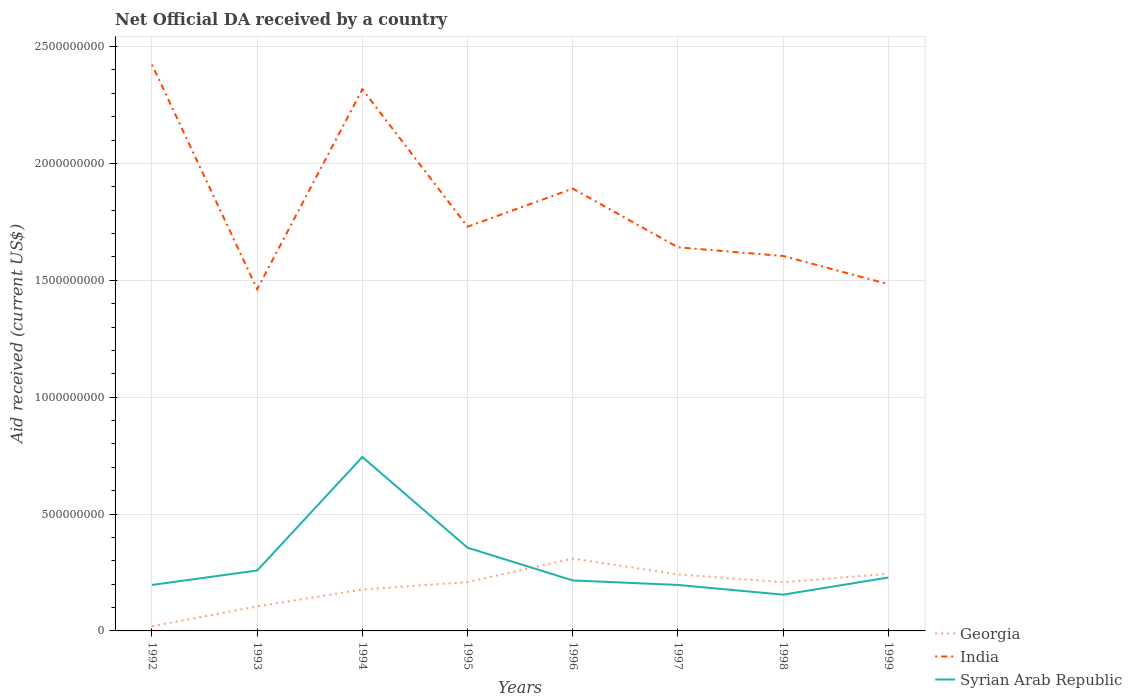How many different coloured lines are there?
Your answer should be very brief. 3. Is the number of lines equal to the number of legend labels?
Your answer should be compact. Yes. Across all years, what is the maximum net official development assistance aid received in Syrian Arab Republic?
Give a very brief answer. 1.55e+08. In which year was the net official development assistance aid received in India maximum?
Provide a short and direct response. 1993. What is the total net official development assistance aid received in Georgia in the graph?
Give a very brief answer. -2.24e+08. What is the difference between the highest and the second highest net official development assistance aid received in Georgia?
Keep it short and to the point. 2.89e+08. What is the difference between the highest and the lowest net official development assistance aid received in India?
Offer a terse response. 3. How many years are there in the graph?
Ensure brevity in your answer.  8. What is the difference between two consecutive major ticks on the Y-axis?
Ensure brevity in your answer.  5.00e+08. How many legend labels are there?
Keep it short and to the point. 3. How are the legend labels stacked?
Provide a short and direct response. Vertical. What is the title of the graph?
Ensure brevity in your answer.  Net Official DA received by a country. What is the label or title of the Y-axis?
Provide a short and direct response. Aid received (current US$). What is the Aid received (current US$) in Georgia in 1992?
Your response must be concise. 2.04e+07. What is the Aid received (current US$) of India in 1992?
Provide a short and direct response. 2.42e+09. What is the Aid received (current US$) in Syrian Arab Republic in 1992?
Provide a short and direct response. 1.97e+08. What is the Aid received (current US$) of Georgia in 1993?
Offer a very short reply. 1.05e+08. What is the Aid received (current US$) of India in 1993?
Offer a very short reply. 1.46e+09. What is the Aid received (current US$) in Syrian Arab Republic in 1993?
Provide a short and direct response. 2.59e+08. What is the Aid received (current US$) in Georgia in 1994?
Keep it short and to the point. 1.77e+08. What is the Aid received (current US$) of India in 1994?
Offer a terse response. 2.32e+09. What is the Aid received (current US$) of Syrian Arab Republic in 1994?
Make the answer very short. 7.44e+08. What is the Aid received (current US$) in Georgia in 1995?
Keep it short and to the point. 2.09e+08. What is the Aid received (current US$) in India in 1995?
Provide a succinct answer. 1.73e+09. What is the Aid received (current US$) of Syrian Arab Republic in 1995?
Your answer should be very brief. 3.56e+08. What is the Aid received (current US$) of Georgia in 1996?
Offer a terse response. 3.09e+08. What is the Aid received (current US$) in India in 1996?
Your response must be concise. 1.89e+09. What is the Aid received (current US$) of Syrian Arab Republic in 1996?
Give a very brief answer. 2.16e+08. What is the Aid received (current US$) in Georgia in 1997?
Your answer should be very brief. 2.42e+08. What is the Aid received (current US$) of India in 1997?
Offer a very short reply. 1.64e+09. What is the Aid received (current US$) of Syrian Arab Republic in 1997?
Ensure brevity in your answer.  1.97e+08. What is the Aid received (current US$) in Georgia in 1998?
Keep it short and to the point. 2.09e+08. What is the Aid received (current US$) of India in 1998?
Ensure brevity in your answer.  1.60e+09. What is the Aid received (current US$) in Syrian Arab Republic in 1998?
Give a very brief answer. 1.55e+08. What is the Aid received (current US$) of Georgia in 1999?
Keep it short and to the point. 2.44e+08. What is the Aid received (current US$) in India in 1999?
Provide a succinct answer. 1.48e+09. What is the Aid received (current US$) in Syrian Arab Republic in 1999?
Offer a terse response. 2.28e+08. Across all years, what is the maximum Aid received (current US$) in Georgia?
Make the answer very short. 3.09e+08. Across all years, what is the maximum Aid received (current US$) in India?
Ensure brevity in your answer.  2.42e+09. Across all years, what is the maximum Aid received (current US$) in Syrian Arab Republic?
Give a very brief answer. 7.44e+08. Across all years, what is the minimum Aid received (current US$) of Georgia?
Offer a terse response. 2.04e+07. Across all years, what is the minimum Aid received (current US$) of India?
Ensure brevity in your answer.  1.46e+09. Across all years, what is the minimum Aid received (current US$) in Syrian Arab Republic?
Give a very brief answer. 1.55e+08. What is the total Aid received (current US$) in Georgia in the graph?
Ensure brevity in your answer.  1.52e+09. What is the total Aid received (current US$) in India in the graph?
Give a very brief answer. 1.46e+1. What is the total Aid received (current US$) of Syrian Arab Republic in the graph?
Keep it short and to the point. 2.35e+09. What is the difference between the Aid received (current US$) of Georgia in 1992 and that in 1993?
Your response must be concise. -8.44e+07. What is the difference between the Aid received (current US$) of India in 1992 and that in 1993?
Provide a short and direct response. 9.61e+08. What is the difference between the Aid received (current US$) of Syrian Arab Republic in 1992 and that in 1993?
Your answer should be compact. -6.18e+07. What is the difference between the Aid received (current US$) in Georgia in 1992 and that in 1994?
Keep it short and to the point. -1.57e+08. What is the difference between the Aid received (current US$) of India in 1992 and that in 1994?
Give a very brief answer. 1.05e+08. What is the difference between the Aid received (current US$) of Syrian Arab Republic in 1992 and that in 1994?
Give a very brief answer. -5.47e+08. What is the difference between the Aid received (current US$) in Georgia in 1992 and that in 1995?
Offer a terse response. -1.89e+08. What is the difference between the Aid received (current US$) in India in 1992 and that in 1995?
Your response must be concise. 6.93e+08. What is the difference between the Aid received (current US$) in Syrian Arab Republic in 1992 and that in 1995?
Provide a short and direct response. -1.59e+08. What is the difference between the Aid received (current US$) of Georgia in 1992 and that in 1996?
Keep it short and to the point. -2.89e+08. What is the difference between the Aid received (current US$) in India in 1992 and that in 1996?
Your answer should be very brief. 5.30e+08. What is the difference between the Aid received (current US$) in Syrian Arab Republic in 1992 and that in 1996?
Ensure brevity in your answer.  -1.92e+07. What is the difference between the Aid received (current US$) in Georgia in 1992 and that in 1997?
Provide a short and direct response. -2.22e+08. What is the difference between the Aid received (current US$) in India in 1992 and that in 1997?
Your response must be concise. 7.82e+08. What is the difference between the Aid received (current US$) of Syrian Arab Republic in 1992 and that in 1997?
Ensure brevity in your answer.  5.00e+04. What is the difference between the Aid received (current US$) in Georgia in 1992 and that in 1998?
Ensure brevity in your answer.  -1.88e+08. What is the difference between the Aid received (current US$) of India in 1992 and that in 1998?
Your response must be concise. 8.19e+08. What is the difference between the Aid received (current US$) of Syrian Arab Republic in 1992 and that in 1998?
Provide a succinct answer. 4.16e+07. What is the difference between the Aid received (current US$) in Georgia in 1992 and that in 1999?
Offer a terse response. -2.24e+08. What is the difference between the Aid received (current US$) of India in 1992 and that in 1999?
Your response must be concise. 9.39e+08. What is the difference between the Aid received (current US$) in Syrian Arab Republic in 1992 and that in 1999?
Keep it short and to the point. -3.18e+07. What is the difference between the Aid received (current US$) in Georgia in 1993 and that in 1994?
Make the answer very short. -7.25e+07. What is the difference between the Aid received (current US$) of India in 1993 and that in 1994?
Your response must be concise. -8.55e+08. What is the difference between the Aid received (current US$) of Syrian Arab Republic in 1993 and that in 1994?
Provide a short and direct response. -4.85e+08. What is the difference between the Aid received (current US$) in Georgia in 1993 and that in 1995?
Offer a very short reply. -1.04e+08. What is the difference between the Aid received (current US$) of India in 1993 and that in 1995?
Offer a terse response. -2.67e+08. What is the difference between the Aid received (current US$) in Syrian Arab Republic in 1993 and that in 1995?
Give a very brief answer. -9.74e+07. What is the difference between the Aid received (current US$) in Georgia in 1993 and that in 1996?
Keep it short and to the point. -2.05e+08. What is the difference between the Aid received (current US$) of India in 1993 and that in 1996?
Your response must be concise. -4.30e+08. What is the difference between the Aid received (current US$) in Syrian Arab Republic in 1993 and that in 1996?
Provide a short and direct response. 4.26e+07. What is the difference between the Aid received (current US$) in Georgia in 1993 and that in 1997?
Give a very brief answer. -1.37e+08. What is the difference between the Aid received (current US$) of India in 1993 and that in 1997?
Keep it short and to the point. -1.79e+08. What is the difference between the Aid received (current US$) of Syrian Arab Republic in 1993 and that in 1997?
Provide a short and direct response. 6.19e+07. What is the difference between the Aid received (current US$) of Georgia in 1993 and that in 1998?
Provide a short and direct response. -1.04e+08. What is the difference between the Aid received (current US$) of India in 1993 and that in 1998?
Your response must be concise. -1.42e+08. What is the difference between the Aid received (current US$) of Syrian Arab Republic in 1993 and that in 1998?
Offer a terse response. 1.03e+08. What is the difference between the Aid received (current US$) of Georgia in 1993 and that in 1999?
Provide a short and direct response. -1.40e+08. What is the difference between the Aid received (current US$) of India in 1993 and that in 1999?
Ensure brevity in your answer.  -2.14e+07. What is the difference between the Aid received (current US$) of Syrian Arab Republic in 1993 and that in 1999?
Your answer should be compact. 3.01e+07. What is the difference between the Aid received (current US$) of Georgia in 1994 and that in 1995?
Provide a short and direct response. -3.17e+07. What is the difference between the Aid received (current US$) of India in 1994 and that in 1995?
Ensure brevity in your answer.  5.88e+08. What is the difference between the Aid received (current US$) in Syrian Arab Republic in 1994 and that in 1995?
Your answer should be compact. 3.88e+08. What is the difference between the Aid received (current US$) in Georgia in 1994 and that in 1996?
Keep it short and to the point. -1.32e+08. What is the difference between the Aid received (current US$) in India in 1994 and that in 1996?
Make the answer very short. 4.25e+08. What is the difference between the Aid received (current US$) of Syrian Arab Republic in 1994 and that in 1996?
Your answer should be very brief. 5.28e+08. What is the difference between the Aid received (current US$) of Georgia in 1994 and that in 1997?
Make the answer very short. -6.46e+07. What is the difference between the Aid received (current US$) of India in 1994 and that in 1997?
Offer a terse response. 6.76e+08. What is the difference between the Aid received (current US$) of Syrian Arab Republic in 1994 and that in 1997?
Make the answer very short. 5.47e+08. What is the difference between the Aid received (current US$) in Georgia in 1994 and that in 1998?
Give a very brief answer. -3.12e+07. What is the difference between the Aid received (current US$) in India in 1994 and that in 1998?
Ensure brevity in your answer.  7.13e+08. What is the difference between the Aid received (current US$) of Syrian Arab Republic in 1994 and that in 1998?
Ensure brevity in your answer.  5.89e+08. What is the difference between the Aid received (current US$) of Georgia in 1994 and that in 1999?
Provide a short and direct response. -6.70e+07. What is the difference between the Aid received (current US$) in India in 1994 and that in 1999?
Give a very brief answer. 8.34e+08. What is the difference between the Aid received (current US$) of Syrian Arab Republic in 1994 and that in 1999?
Offer a terse response. 5.16e+08. What is the difference between the Aid received (current US$) of Georgia in 1995 and that in 1996?
Give a very brief answer. -1.00e+08. What is the difference between the Aid received (current US$) in India in 1995 and that in 1996?
Your response must be concise. -1.63e+08. What is the difference between the Aid received (current US$) of Syrian Arab Republic in 1995 and that in 1996?
Give a very brief answer. 1.40e+08. What is the difference between the Aid received (current US$) of Georgia in 1995 and that in 1997?
Provide a succinct answer. -3.28e+07. What is the difference between the Aid received (current US$) in India in 1995 and that in 1997?
Provide a short and direct response. 8.81e+07. What is the difference between the Aid received (current US$) in Syrian Arab Republic in 1995 and that in 1997?
Your response must be concise. 1.59e+08. What is the difference between the Aid received (current US$) of Georgia in 1995 and that in 1998?
Offer a very short reply. 5.40e+05. What is the difference between the Aid received (current US$) in India in 1995 and that in 1998?
Your answer should be compact. 1.25e+08. What is the difference between the Aid received (current US$) of Syrian Arab Republic in 1995 and that in 1998?
Make the answer very short. 2.01e+08. What is the difference between the Aid received (current US$) of Georgia in 1995 and that in 1999?
Your answer should be very brief. -3.53e+07. What is the difference between the Aid received (current US$) of India in 1995 and that in 1999?
Your response must be concise. 2.46e+08. What is the difference between the Aid received (current US$) in Syrian Arab Republic in 1995 and that in 1999?
Ensure brevity in your answer.  1.27e+08. What is the difference between the Aid received (current US$) of Georgia in 1996 and that in 1997?
Ensure brevity in your answer.  6.75e+07. What is the difference between the Aid received (current US$) of India in 1996 and that in 1997?
Make the answer very short. 2.51e+08. What is the difference between the Aid received (current US$) in Syrian Arab Republic in 1996 and that in 1997?
Your response must be concise. 1.93e+07. What is the difference between the Aid received (current US$) of Georgia in 1996 and that in 1998?
Your response must be concise. 1.01e+08. What is the difference between the Aid received (current US$) of India in 1996 and that in 1998?
Your response must be concise. 2.88e+08. What is the difference between the Aid received (current US$) of Syrian Arab Republic in 1996 and that in 1998?
Offer a terse response. 6.08e+07. What is the difference between the Aid received (current US$) in Georgia in 1996 and that in 1999?
Keep it short and to the point. 6.50e+07. What is the difference between the Aid received (current US$) of India in 1996 and that in 1999?
Offer a terse response. 4.09e+08. What is the difference between the Aid received (current US$) in Syrian Arab Republic in 1996 and that in 1999?
Provide a short and direct response. -1.25e+07. What is the difference between the Aid received (current US$) of Georgia in 1997 and that in 1998?
Keep it short and to the point. 3.34e+07. What is the difference between the Aid received (current US$) in India in 1997 and that in 1998?
Your answer should be very brief. 3.71e+07. What is the difference between the Aid received (current US$) in Syrian Arab Republic in 1997 and that in 1998?
Give a very brief answer. 4.16e+07. What is the difference between the Aid received (current US$) in Georgia in 1997 and that in 1999?
Provide a succinct answer. -2.46e+06. What is the difference between the Aid received (current US$) in India in 1997 and that in 1999?
Offer a very short reply. 1.58e+08. What is the difference between the Aid received (current US$) of Syrian Arab Republic in 1997 and that in 1999?
Ensure brevity in your answer.  -3.18e+07. What is the difference between the Aid received (current US$) of Georgia in 1998 and that in 1999?
Ensure brevity in your answer.  -3.58e+07. What is the difference between the Aid received (current US$) of India in 1998 and that in 1999?
Offer a terse response. 1.21e+08. What is the difference between the Aid received (current US$) of Syrian Arab Republic in 1998 and that in 1999?
Provide a short and direct response. -7.34e+07. What is the difference between the Aid received (current US$) of Georgia in 1992 and the Aid received (current US$) of India in 1993?
Your answer should be very brief. -1.44e+09. What is the difference between the Aid received (current US$) of Georgia in 1992 and the Aid received (current US$) of Syrian Arab Republic in 1993?
Provide a succinct answer. -2.38e+08. What is the difference between the Aid received (current US$) in India in 1992 and the Aid received (current US$) in Syrian Arab Republic in 1993?
Give a very brief answer. 2.16e+09. What is the difference between the Aid received (current US$) of Georgia in 1992 and the Aid received (current US$) of India in 1994?
Keep it short and to the point. -2.30e+09. What is the difference between the Aid received (current US$) in Georgia in 1992 and the Aid received (current US$) in Syrian Arab Republic in 1994?
Make the answer very short. -7.24e+08. What is the difference between the Aid received (current US$) of India in 1992 and the Aid received (current US$) of Syrian Arab Republic in 1994?
Provide a short and direct response. 1.68e+09. What is the difference between the Aid received (current US$) of Georgia in 1992 and the Aid received (current US$) of India in 1995?
Offer a very short reply. -1.71e+09. What is the difference between the Aid received (current US$) of Georgia in 1992 and the Aid received (current US$) of Syrian Arab Republic in 1995?
Offer a terse response. -3.36e+08. What is the difference between the Aid received (current US$) in India in 1992 and the Aid received (current US$) in Syrian Arab Republic in 1995?
Your answer should be very brief. 2.07e+09. What is the difference between the Aid received (current US$) in Georgia in 1992 and the Aid received (current US$) in India in 1996?
Give a very brief answer. -1.87e+09. What is the difference between the Aid received (current US$) of Georgia in 1992 and the Aid received (current US$) of Syrian Arab Republic in 1996?
Provide a succinct answer. -1.96e+08. What is the difference between the Aid received (current US$) in India in 1992 and the Aid received (current US$) in Syrian Arab Republic in 1996?
Give a very brief answer. 2.21e+09. What is the difference between the Aid received (current US$) in Georgia in 1992 and the Aid received (current US$) in India in 1997?
Your response must be concise. -1.62e+09. What is the difference between the Aid received (current US$) of Georgia in 1992 and the Aid received (current US$) of Syrian Arab Republic in 1997?
Offer a very short reply. -1.76e+08. What is the difference between the Aid received (current US$) of India in 1992 and the Aid received (current US$) of Syrian Arab Republic in 1997?
Your answer should be compact. 2.23e+09. What is the difference between the Aid received (current US$) of Georgia in 1992 and the Aid received (current US$) of India in 1998?
Make the answer very short. -1.58e+09. What is the difference between the Aid received (current US$) of Georgia in 1992 and the Aid received (current US$) of Syrian Arab Republic in 1998?
Your response must be concise. -1.35e+08. What is the difference between the Aid received (current US$) of India in 1992 and the Aid received (current US$) of Syrian Arab Republic in 1998?
Your answer should be very brief. 2.27e+09. What is the difference between the Aid received (current US$) in Georgia in 1992 and the Aid received (current US$) in India in 1999?
Your response must be concise. -1.46e+09. What is the difference between the Aid received (current US$) in Georgia in 1992 and the Aid received (current US$) in Syrian Arab Republic in 1999?
Provide a succinct answer. -2.08e+08. What is the difference between the Aid received (current US$) of India in 1992 and the Aid received (current US$) of Syrian Arab Republic in 1999?
Your answer should be very brief. 2.19e+09. What is the difference between the Aid received (current US$) in Georgia in 1993 and the Aid received (current US$) in India in 1994?
Make the answer very short. -2.21e+09. What is the difference between the Aid received (current US$) of Georgia in 1993 and the Aid received (current US$) of Syrian Arab Republic in 1994?
Make the answer very short. -6.39e+08. What is the difference between the Aid received (current US$) of India in 1993 and the Aid received (current US$) of Syrian Arab Republic in 1994?
Offer a very short reply. 7.18e+08. What is the difference between the Aid received (current US$) of Georgia in 1993 and the Aid received (current US$) of India in 1995?
Keep it short and to the point. -1.62e+09. What is the difference between the Aid received (current US$) in Georgia in 1993 and the Aid received (current US$) in Syrian Arab Republic in 1995?
Offer a very short reply. -2.51e+08. What is the difference between the Aid received (current US$) in India in 1993 and the Aid received (current US$) in Syrian Arab Republic in 1995?
Your response must be concise. 1.11e+09. What is the difference between the Aid received (current US$) of Georgia in 1993 and the Aid received (current US$) of India in 1996?
Your answer should be very brief. -1.79e+09. What is the difference between the Aid received (current US$) of Georgia in 1993 and the Aid received (current US$) of Syrian Arab Republic in 1996?
Your response must be concise. -1.11e+08. What is the difference between the Aid received (current US$) of India in 1993 and the Aid received (current US$) of Syrian Arab Republic in 1996?
Ensure brevity in your answer.  1.25e+09. What is the difference between the Aid received (current US$) of Georgia in 1993 and the Aid received (current US$) of India in 1997?
Make the answer very short. -1.54e+09. What is the difference between the Aid received (current US$) of Georgia in 1993 and the Aid received (current US$) of Syrian Arab Republic in 1997?
Offer a terse response. -9.19e+07. What is the difference between the Aid received (current US$) of India in 1993 and the Aid received (current US$) of Syrian Arab Republic in 1997?
Make the answer very short. 1.27e+09. What is the difference between the Aid received (current US$) in Georgia in 1993 and the Aid received (current US$) in India in 1998?
Your answer should be compact. -1.50e+09. What is the difference between the Aid received (current US$) of Georgia in 1993 and the Aid received (current US$) of Syrian Arab Republic in 1998?
Make the answer very short. -5.04e+07. What is the difference between the Aid received (current US$) in India in 1993 and the Aid received (current US$) in Syrian Arab Republic in 1998?
Provide a short and direct response. 1.31e+09. What is the difference between the Aid received (current US$) of Georgia in 1993 and the Aid received (current US$) of India in 1999?
Your answer should be compact. -1.38e+09. What is the difference between the Aid received (current US$) in Georgia in 1993 and the Aid received (current US$) in Syrian Arab Republic in 1999?
Your response must be concise. -1.24e+08. What is the difference between the Aid received (current US$) of India in 1993 and the Aid received (current US$) of Syrian Arab Republic in 1999?
Keep it short and to the point. 1.23e+09. What is the difference between the Aid received (current US$) in Georgia in 1994 and the Aid received (current US$) in India in 1995?
Keep it short and to the point. -1.55e+09. What is the difference between the Aid received (current US$) of Georgia in 1994 and the Aid received (current US$) of Syrian Arab Republic in 1995?
Your response must be concise. -1.79e+08. What is the difference between the Aid received (current US$) in India in 1994 and the Aid received (current US$) in Syrian Arab Republic in 1995?
Provide a succinct answer. 1.96e+09. What is the difference between the Aid received (current US$) of Georgia in 1994 and the Aid received (current US$) of India in 1996?
Make the answer very short. -1.72e+09. What is the difference between the Aid received (current US$) of Georgia in 1994 and the Aid received (current US$) of Syrian Arab Republic in 1996?
Make the answer very short. -3.87e+07. What is the difference between the Aid received (current US$) in India in 1994 and the Aid received (current US$) in Syrian Arab Republic in 1996?
Ensure brevity in your answer.  2.10e+09. What is the difference between the Aid received (current US$) in Georgia in 1994 and the Aid received (current US$) in India in 1997?
Offer a very short reply. -1.46e+09. What is the difference between the Aid received (current US$) in Georgia in 1994 and the Aid received (current US$) in Syrian Arab Republic in 1997?
Offer a terse response. -1.94e+07. What is the difference between the Aid received (current US$) in India in 1994 and the Aid received (current US$) in Syrian Arab Republic in 1997?
Provide a short and direct response. 2.12e+09. What is the difference between the Aid received (current US$) of Georgia in 1994 and the Aid received (current US$) of India in 1998?
Your response must be concise. -1.43e+09. What is the difference between the Aid received (current US$) in Georgia in 1994 and the Aid received (current US$) in Syrian Arab Republic in 1998?
Provide a succinct answer. 2.22e+07. What is the difference between the Aid received (current US$) in India in 1994 and the Aid received (current US$) in Syrian Arab Republic in 1998?
Make the answer very short. 2.16e+09. What is the difference between the Aid received (current US$) of Georgia in 1994 and the Aid received (current US$) of India in 1999?
Provide a short and direct response. -1.31e+09. What is the difference between the Aid received (current US$) of Georgia in 1994 and the Aid received (current US$) of Syrian Arab Republic in 1999?
Your response must be concise. -5.12e+07. What is the difference between the Aid received (current US$) of India in 1994 and the Aid received (current US$) of Syrian Arab Republic in 1999?
Offer a terse response. 2.09e+09. What is the difference between the Aid received (current US$) of Georgia in 1995 and the Aid received (current US$) of India in 1996?
Your answer should be compact. -1.68e+09. What is the difference between the Aid received (current US$) in Georgia in 1995 and the Aid received (current US$) in Syrian Arab Republic in 1996?
Give a very brief answer. -6.93e+06. What is the difference between the Aid received (current US$) of India in 1995 and the Aid received (current US$) of Syrian Arab Republic in 1996?
Your answer should be compact. 1.51e+09. What is the difference between the Aid received (current US$) in Georgia in 1995 and the Aid received (current US$) in India in 1997?
Ensure brevity in your answer.  -1.43e+09. What is the difference between the Aid received (current US$) in Georgia in 1995 and the Aid received (current US$) in Syrian Arab Republic in 1997?
Give a very brief answer. 1.24e+07. What is the difference between the Aid received (current US$) of India in 1995 and the Aid received (current US$) of Syrian Arab Republic in 1997?
Make the answer very short. 1.53e+09. What is the difference between the Aid received (current US$) in Georgia in 1995 and the Aid received (current US$) in India in 1998?
Offer a very short reply. -1.40e+09. What is the difference between the Aid received (current US$) in Georgia in 1995 and the Aid received (current US$) in Syrian Arab Republic in 1998?
Make the answer very short. 5.39e+07. What is the difference between the Aid received (current US$) of India in 1995 and the Aid received (current US$) of Syrian Arab Republic in 1998?
Give a very brief answer. 1.57e+09. What is the difference between the Aid received (current US$) of Georgia in 1995 and the Aid received (current US$) of India in 1999?
Your answer should be compact. -1.27e+09. What is the difference between the Aid received (current US$) in Georgia in 1995 and the Aid received (current US$) in Syrian Arab Republic in 1999?
Offer a terse response. -1.94e+07. What is the difference between the Aid received (current US$) of India in 1995 and the Aid received (current US$) of Syrian Arab Republic in 1999?
Provide a short and direct response. 1.50e+09. What is the difference between the Aid received (current US$) of Georgia in 1996 and the Aid received (current US$) of India in 1997?
Provide a short and direct response. -1.33e+09. What is the difference between the Aid received (current US$) in Georgia in 1996 and the Aid received (current US$) in Syrian Arab Republic in 1997?
Make the answer very short. 1.13e+08. What is the difference between the Aid received (current US$) in India in 1996 and the Aid received (current US$) in Syrian Arab Republic in 1997?
Offer a very short reply. 1.70e+09. What is the difference between the Aid received (current US$) in Georgia in 1996 and the Aid received (current US$) in India in 1998?
Your answer should be compact. -1.29e+09. What is the difference between the Aid received (current US$) of Georgia in 1996 and the Aid received (current US$) of Syrian Arab Republic in 1998?
Ensure brevity in your answer.  1.54e+08. What is the difference between the Aid received (current US$) in India in 1996 and the Aid received (current US$) in Syrian Arab Republic in 1998?
Make the answer very short. 1.74e+09. What is the difference between the Aid received (current US$) of Georgia in 1996 and the Aid received (current US$) of India in 1999?
Offer a terse response. -1.17e+09. What is the difference between the Aid received (current US$) of Georgia in 1996 and the Aid received (current US$) of Syrian Arab Republic in 1999?
Your response must be concise. 8.09e+07. What is the difference between the Aid received (current US$) in India in 1996 and the Aid received (current US$) in Syrian Arab Republic in 1999?
Your answer should be compact. 1.66e+09. What is the difference between the Aid received (current US$) of Georgia in 1997 and the Aid received (current US$) of India in 1998?
Ensure brevity in your answer.  -1.36e+09. What is the difference between the Aid received (current US$) in Georgia in 1997 and the Aid received (current US$) in Syrian Arab Republic in 1998?
Your answer should be very brief. 8.67e+07. What is the difference between the Aid received (current US$) in India in 1997 and the Aid received (current US$) in Syrian Arab Republic in 1998?
Your response must be concise. 1.49e+09. What is the difference between the Aid received (current US$) of Georgia in 1997 and the Aid received (current US$) of India in 1999?
Offer a terse response. -1.24e+09. What is the difference between the Aid received (current US$) of Georgia in 1997 and the Aid received (current US$) of Syrian Arab Republic in 1999?
Provide a short and direct response. 1.34e+07. What is the difference between the Aid received (current US$) of India in 1997 and the Aid received (current US$) of Syrian Arab Republic in 1999?
Your response must be concise. 1.41e+09. What is the difference between the Aid received (current US$) of Georgia in 1998 and the Aid received (current US$) of India in 1999?
Offer a very short reply. -1.28e+09. What is the difference between the Aid received (current US$) of Georgia in 1998 and the Aid received (current US$) of Syrian Arab Republic in 1999?
Provide a succinct answer. -2.00e+07. What is the difference between the Aid received (current US$) in India in 1998 and the Aid received (current US$) in Syrian Arab Republic in 1999?
Your answer should be compact. 1.38e+09. What is the average Aid received (current US$) of Georgia per year?
Offer a terse response. 1.89e+08. What is the average Aid received (current US$) of India per year?
Provide a short and direct response. 1.82e+09. What is the average Aid received (current US$) of Syrian Arab Republic per year?
Offer a terse response. 2.94e+08. In the year 1992, what is the difference between the Aid received (current US$) of Georgia and Aid received (current US$) of India?
Your answer should be compact. -2.40e+09. In the year 1992, what is the difference between the Aid received (current US$) of Georgia and Aid received (current US$) of Syrian Arab Republic?
Your answer should be very brief. -1.76e+08. In the year 1992, what is the difference between the Aid received (current US$) in India and Aid received (current US$) in Syrian Arab Republic?
Offer a very short reply. 2.23e+09. In the year 1993, what is the difference between the Aid received (current US$) in Georgia and Aid received (current US$) in India?
Your answer should be compact. -1.36e+09. In the year 1993, what is the difference between the Aid received (current US$) of Georgia and Aid received (current US$) of Syrian Arab Republic?
Provide a succinct answer. -1.54e+08. In the year 1993, what is the difference between the Aid received (current US$) of India and Aid received (current US$) of Syrian Arab Republic?
Give a very brief answer. 1.20e+09. In the year 1994, what is the difference between the Aid received (current US$) of Georgia and Aid received (current US$) of India?
Your response must be concise. -2.14e+09. In the year 1994, what is the difference between the Aid received (current US$) of Georgia and Aid received (current US$) of Syrian Arab Republic?
Keep it short and to the point. -5.67e+08. In the year 1994, what is the difference between the Aid received (current US$) of India and Aid received (current US$) of Syrian Arab Republic?
Make the answer very short. 1.57e+09. In the year 1995, what is the difference between the Aid received (current US$) of Georgia and Aid received (current US$) of India?
Offer a terse response. -1.52e+09. In the year 1995, what is the difference between the Aid received (current US$) of Georgia and Aid received (current US$) of Syrian Arab Republic?
Your answer should be very brief. -1.47e+08. In the year 1995, what is the difference between the Aid received (current US$) in India and Aid received (current US$) in Syrian Arab Republic?
Ensure brevity in your answer.  1.37e+09. In the year 1996, what is the difference between the Aid received (current US$) in Georgia and Aid received (current US$) in India?
Your answer should be compact. -1.58e+09. In the year 1996, what is the difference between the Aid received (current US$) of Georgia and Aid received (current US$) of Syrian Arab Republic?
Make the answer very short. 9.34e+07. In the year 1996, what is the difference between the Aid received (current US$) of India and Aid received (current US$) of Syrian Arab Republic?
Give a very brief answer. 1.68e+09. In the year 1997, what is the difference between the Aid received (current US$) in Georgia and Aid received (current US$) in India?
Make the answer very short. -1.40e+09. In the year 1997, what is the difference between the Aid received (current US$) in Georgia and Aid received (current US$) in Syrian Arab Republic?
Make the answer very short. 4.52e+07. In the year 1997, what is the difference between the Aid received (current US$) in India and Aid received (current US$) in Syrian Arab Republic?
Make the answer very short. 1.44e+09. In the year 1998, what is the difference between the Aid received (current US$) of Georgia and Aid received (current US$) of India?
Provide a short and direct response. -1.40e+09. In the year 1998, what is the difference between the Aid received (current US$) in Georgia and Aid received (current US$) in Syrian Arab Republic?
Ensure brevity in your answer.  5.34e+07. In the year 1998, what is the difference between the Aid received (current US$) of India and Aid received (current US$) of Syrian Arab Republic?
Ensure brevity in your answer.  1.45e+09. In the year 1999, what is the difference between the Aid received (current US$) of Georgia and Aid received (current US$) of India?
Ensure brevity in your answer.  -1.24e+09. In the year 1999, what is the difference between the Aid received (current US$) in Georgia and Aid received (current US$) in Syrian Arab Republic?
Make the answer very short. 1.58e+07. In the year 1999, what is the difference between the Aid received (current US$) in India and Aid received (current US$) in Syrian Arab Republic?
Provide a succinct answer. 1.26e+09. What is the ratio of the Aid received (current US$) in Georgia in 1992 to that in 1993?
Provide a short and direct response. 0.19. What is the ratio of the Aid received (current US$) of India in 1992 to that in 1993?
Offer a terse response. 1.66. What is the ratio of the Aid received (current US$) in Syrian Arab Republic in 1992 to that in 1993?
Your response must be concise. 0.76. What is the ratio of the Aid received (current US$) in Georgia in 1992 to that in 1994?
Offer a terse response. 0.11. What is the ratio of the Aid received (current US$) of India in 1992 to that in 1994?
Your answer should be compact. 1.05. What is the ratio of the Aid received (current US$) of Syrian Arab Republic in 1992 to that in 1994?
Provide a short and direct response. 0.26. What is the ratio of the Aid received (current US$) of Georgia in 1992 to that in 1995?
Your answer should be compact. 0.1. What is the ratio of the Aid received (current US$) of India in 1992 to that in 1995?
Give a very brief answer. 1.4. What is the ratio of the Aid received (current US$) in Syrian Arab Republic in 1992 to that in 1995?
Your response must be concise. 0.55. What is the ratio of the Aid received (current US$) in Georgia in 1992 to that in 1996?
Give a very brief answer. 0.07. What is the ratio of the Aid received (current US$) of India in 1992 to that in 1996?
Offer a terse response. 1.28. What is the ratio of the Aid received (current US$) of Syrian Arab Republic in 1992 to that in 1996?
Give a very brief answer. 0.91. What is the ratio of the Aid received (current US$) of Georgia in 1992 to that in 1997?
Make the answer very short. 0.08. What is the ratio of the Aid received (current US$) in India in 1992 to that in 1997?
Ensure brevity in your answer.  1.48. What is the ratio of the Aid received (current US$) of Georgia in 1992 to that in 1998?
Your answer should be very brief. 0.1. What is the ratio of the Aid received (current US$) of India in 1992 to that in 1998?
Give a very brief answer. 1.51. What is the ratio of the Aid received (current US$) of Syrian Arab Republic in 1992 to that in 1998?
Offer a terse response. 1.27. What is the ratio of the Aid received (current US$) of Georgia in 1992 to that in 1999?
Your response must be concise. 0.08. What is the ratio of the Aid received (current US$) of India in 1992 to that in 1999?
Provide a succinct answer. 1.63. What is the ratio of the Aid received (current US$) of Syrian Arab Republic in 1992 to that in 1999?
Provide a short and direct response. 0.86. What is the ratio of the Aid received (current US$) of Georgia in 1993 to that in 1994?
Give a very brief answer. 0.59. What is the ratio of the Aid received (current US$) in India in 1993 to that in 1994?
Provide a short and direct response. 0.63. What is the ratio of the Aid received (current US$) in Syrian Arab Republic in 1993 to that in 1994?
Give a very brief answer. 0.35. What is the ratio of the Aid received (current US$) in Georgia in 1993 to that in 1995?
Offer a very short reply. 0.5. What is the ratio of the Aid received (current US$) of India in 1993 to that in 1995?
Give a very brief answer. 0.85. What is the ratio of the Aid received (current US$) in Syrian Arab Republic in 1993 to that in 1995?
Ensure brevity in your answer.  0.73. What is the ratio of the Aid received (current US$) in Georgia in 1993 to that in 1996?
Ensure brevity in your answer.  0.34. What is the ratio of the Aid received (current US$) in India in 1993 to that in 1996?
Your response must be concise. 0.77. What is the ratio of the Aid received (current US$) of Syrian Arab Republic in 1993 to that in 1996?
Offer a terse response. 1.2. What is the ratio of the Aid received (current US$) in Georgia in 1993 to that in 1997?
Your answer should be very brief. 0.43. What is the ratio of the Aid received (current US$) in India in 1993 to that in 1997?
Offer a very short reply. 0.89. What is the ratio of the Aid received (current US$) of Syrian Arab Republic in 1993 to that in 1997?
Keep it short and to the point. 1.31. What is the ratio of the Aid received (current US$) of Georgia in 1993 to that in 1998?
Offer a terse response. 0.5. What is the ratio of the Aid received (current US$) in India in 1993 to that in 1998?
Provide a succinct answer. 0.91. What is the ratio of the Aid received (current US$) of Syrian Arab Republic in 1993 to that in 1998?
Make the answer very short. 1.67. What is the ratio of the Aid received (current US$) in Georgia in 1993 to that in 1999?
Provide a succinct answer. 0.43. What is the ratio of the Aid received (current US$) of India in 1993 to that in 1999?
Your answer should be compact. 0.99. What is the ratio of the Aid received (current US$) in Syrian Arab Republic in 1993 to that in 1999?
Ensure brevity in your answer.  1.13. What is the ratio of the Aid received (current US$) in Georgia in 1994 to that in 1995?
Your response must be concise. 0.85. What is the ratio of the Aid received (current US$) of India in 1994 to that in 1995?
Give a very brief answer. 1.34. What is the ratio of the Aid received (current US$) in Syrian Arab Republic in 1994 to that in 1995?
Offer a very short reply. 2.09. What is the ratio of the Aid received (current US$) of Georgia in 1994 to that in 1996?
Offer a terse response. 0.57. What is the ratio of the Aid received (current US$) in India in 1994 to that in 1996?
Your response must be concise. 1.22. What is the ratio of the Aid received (current US$) in Syrian Arab Republic in 1994 to that in 1996?
Your response must be concise. 3.44. What is the ratio of the Aid received (current US$) of Georgia in 1994 to that in 1997?
Your answer should be very brief. 0.73. What is the ratio of the Aid received (current US$) in India in 1994 to that in 1997?
Provide a short and direct response. 1.41. What is the ratio of the Aid received (current US$) of Syrian Arab Republic in 1994 to that in 1997?
Offer a terse response. 3.78. What is the ratio of the Aid received (current US$) in Georgia in 1994 to that in 1998?
Your response must be concise. 0.85. What is the ratio of the Aid received (current US$) of India in 1994 to that in 1998?
Provide a short and direct response. 1.44. What is the ratio of the Aid received (current US$) of Syrian Arab Republic in 1994 to that in 1998?
Make the answer very short. 4.8. What is the ratio of the Aid received (current US$) of Georgia in 1994 to that in 1999?
Make the answer very short. 0.73. What is the ratio of the Aid received (current US$) in India in 1994 to that in 1999?
Ensure brevity in your answer.  1.56. What is the ratio of the Aid received (current US$) of Syrian Arab Republic in 1994 to that in 1999?
Your answer should be compact. 3.26. What is the ratio of the Aid received (current US$) in Georgia in 1995 to that in 1996?
Your answer should be compact. 0.68. What is the ratio of the Aid received (current US$) of India in 1995 to that in 1996?
Give a very brief answer. 0.91. What is the ratio of the Aid received (current US$) in Syrian Arab Republic in 1995 to that in 1996?
Offer a terse response. 1.65. What is the ratio of the Aid received (current US$) of Georgia in 1995 to that in 1997?
Offer a very short reply. 0.86. What is the ratio of the Aid received (current US$) of India in 1995 to that in 1997?
Your answer should be compact. 1.05. What is the ratio of the Aid received (current US$) in Syrian Arab Republic in 1995 to that in 1997?
Your answer should be very brief. 1.81. What is the ratio of the Aid received (current US$) in India in 1995 to that in 1998?
Offer a terse response. 1.08. What is the ratio of the Aid received (current US$) in Syrian Arab Republic in 1995 to that in 1998?
Offer a terse response. 2.29. What is the ratio of the Aid received (current US$) of Georgia in 1995 to that in 1999?
Your response must be concise. 0.86. What is the ratio of the Aid received (current US$) in India in 1995 to that in 1999?
Your answer should be compact. 1.17. What is the ratio of the Aid received (current US$) of Syrian Arab Republic in 1995 to that in 1999?
Offer a very short reply. 1.56. What is the ratio of the Aid received (current US$) in Georgia in 1996 to that in 1997?
Offer a terse response. 1.28. What is the ratio of the Aid received (current US$) in India in 1996 to that in 1997?
Your response must be concise. 1.15. What is the ratio of the Aid received (current US$) of Syrian Arab Republic in 1996 to that in 1997?
Your answer should be very brief. 1.1. What is the ratio of the Aid received (current US$) in Georgia in 1996 to that in 1998?
Offer a terse response. 1.48. What is the ratio of the Aid received (current US$) of India in 1996 to that in 1998?
Give a very brief answer. 1.18. What is the ratio of the Aid received (current US$) in Syrian Arab Republic in 1996 to that in 1998?
Offer a terse response. 1.39. What is the ratio of the Aid received (current US$) in Georgia in 1996 to that in 1999?
Provide a short and direct response. 1.27. What is the ratio of the Aid received (current US$) in India in 1996 to that in 1999?
Give a very brief answer. 1.28. What is the ratio of the Aid received (current US$) of Syrian Arab Republic in 1996 to that in 1999?
Make the answer very short. 0.95. What is the ratio of the Aid received (current US$) in Georgia in 1997 to that in 1998?
Offer a very short reply. 1.16. What is the ratio of the Aid received (current US$) of India in 1997 to that in 1998?
Ensure brevity in your answer.  1.02. What is the ratio of the Aid received (current US$) of Syrian Arab Republic in 1997 to that in 1998?
Offer a terse response. 1.27. What is the ratio of the Aid received (current US$) of India in 1997 to that in 1999?
Ensure brevity in your answer.  1.11. What is the ratio of the Aid received (current US$) of Syrian Arab Republic in 1997 to that in 1999?
Provide a short and direct response. 0.86. What is the ratio of the Aid received (current US$) in Georgia in 1998 to that in 1999?
Make the answer very short. 0.85. What is the ratio of the Aid received (current US$) of India in 1998 to that in 1999?
Provide a short and direct response. 1.08. What is the ratio of the Aid received (current US$) in Syrian Arab Republic in 1998 to that in 1999?
Your response must be concise. 0.68. What is the difference between the highest and the second highest Aid received (current US$) of Georgia?
Keep it short and to the point. 6.50e+07. What is the difference between the highest and the second highest Aid received (current US$) of India?
Offer a terse response. 1.05e+08. What is the difference between the highest and the second highest Aid received (current US$) in Syrian Arab Republic?
Ensure brevity in your answer.  3.88e+08. What is the difference between the highest and the lowest Aid received (current US$) of Georgia?
Provide a short and direct response. 2.89e+08. What is the difference between the highest and the lowest Aid received (current US$) in India?
Give a very brief answer. 9.61e+08. What is the difference between the highest and the lowest Aid received (current US$) of Syrian Arab Republic?
Give a very brief answer. 5.89e+08. 